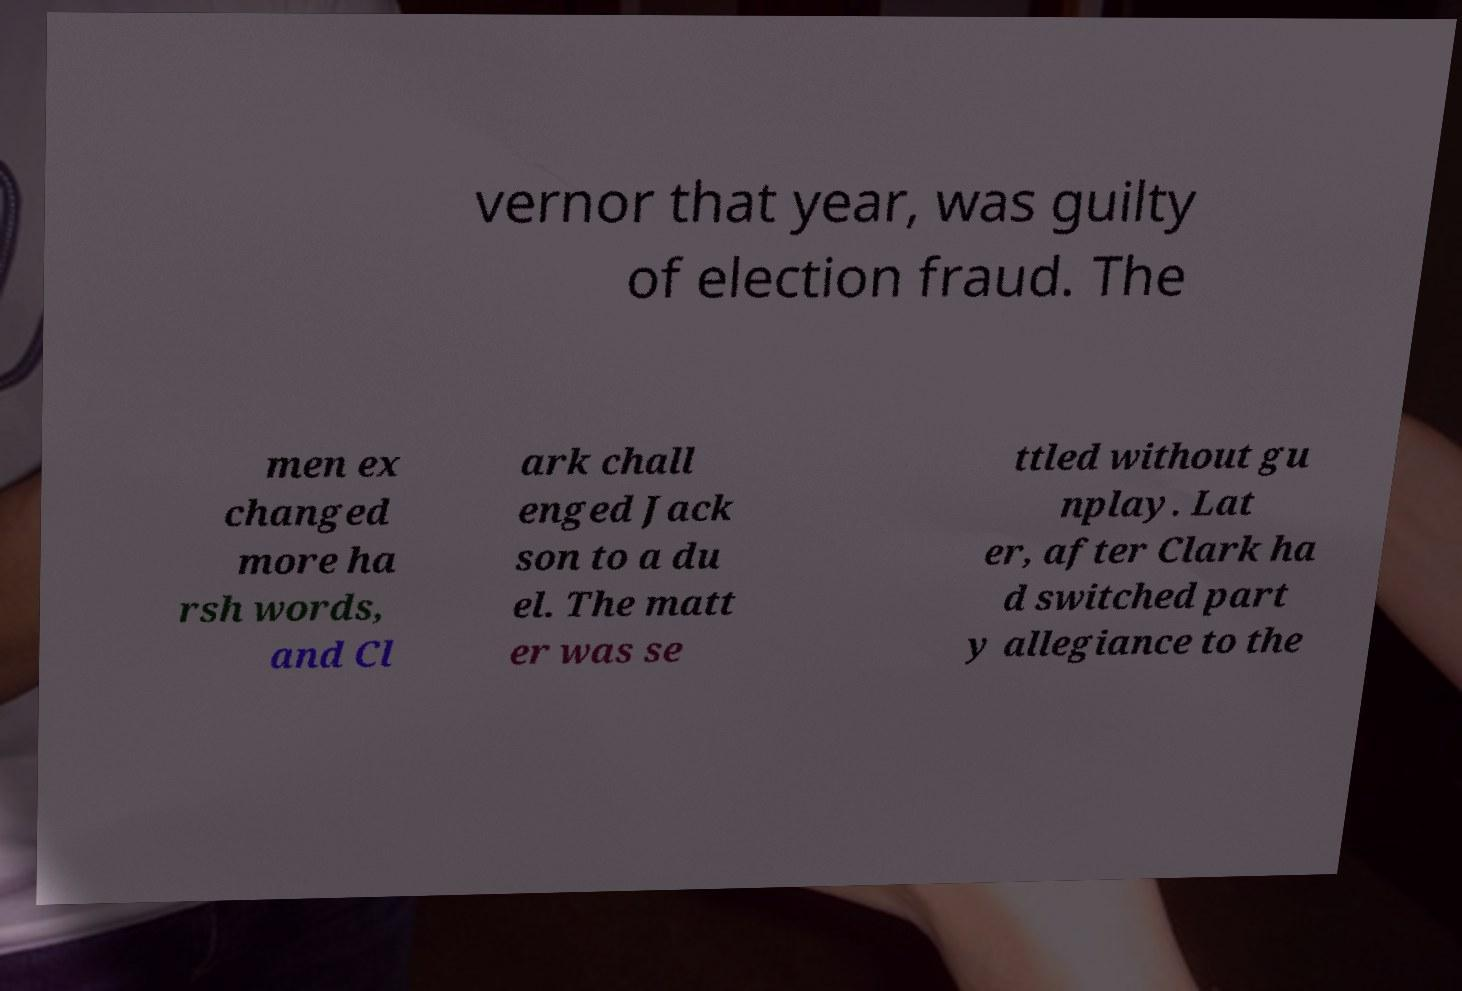Please read and relay the text visible in this image. What does it say? vernor that year, was guilty of election fraud. The men ex changed more ha rsh words, and Cl ark chall enged Jack son to a du el. The matt er was se ttled without gu nplay. Lat er, after Clark ha d switched part y allegiance to the 